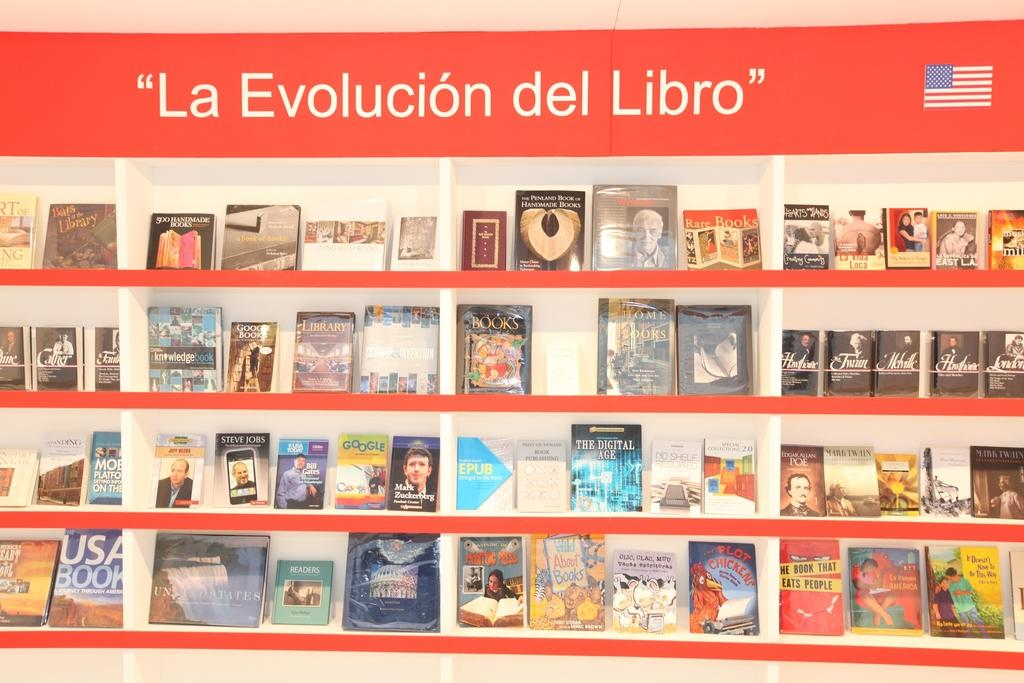<image>
Relay a brief, clear account of the picture shown. A book shelf labeled "La Evolucion del Libro" 